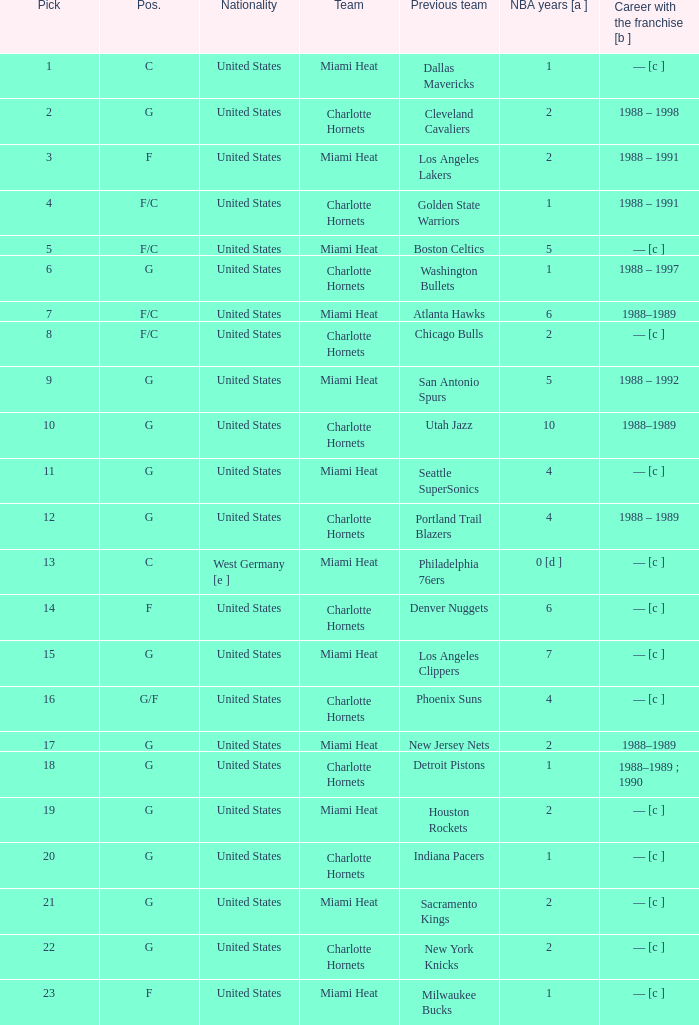How many NBA years did the player from the United States who was previously on the los angeles lakers have? 2.0. 